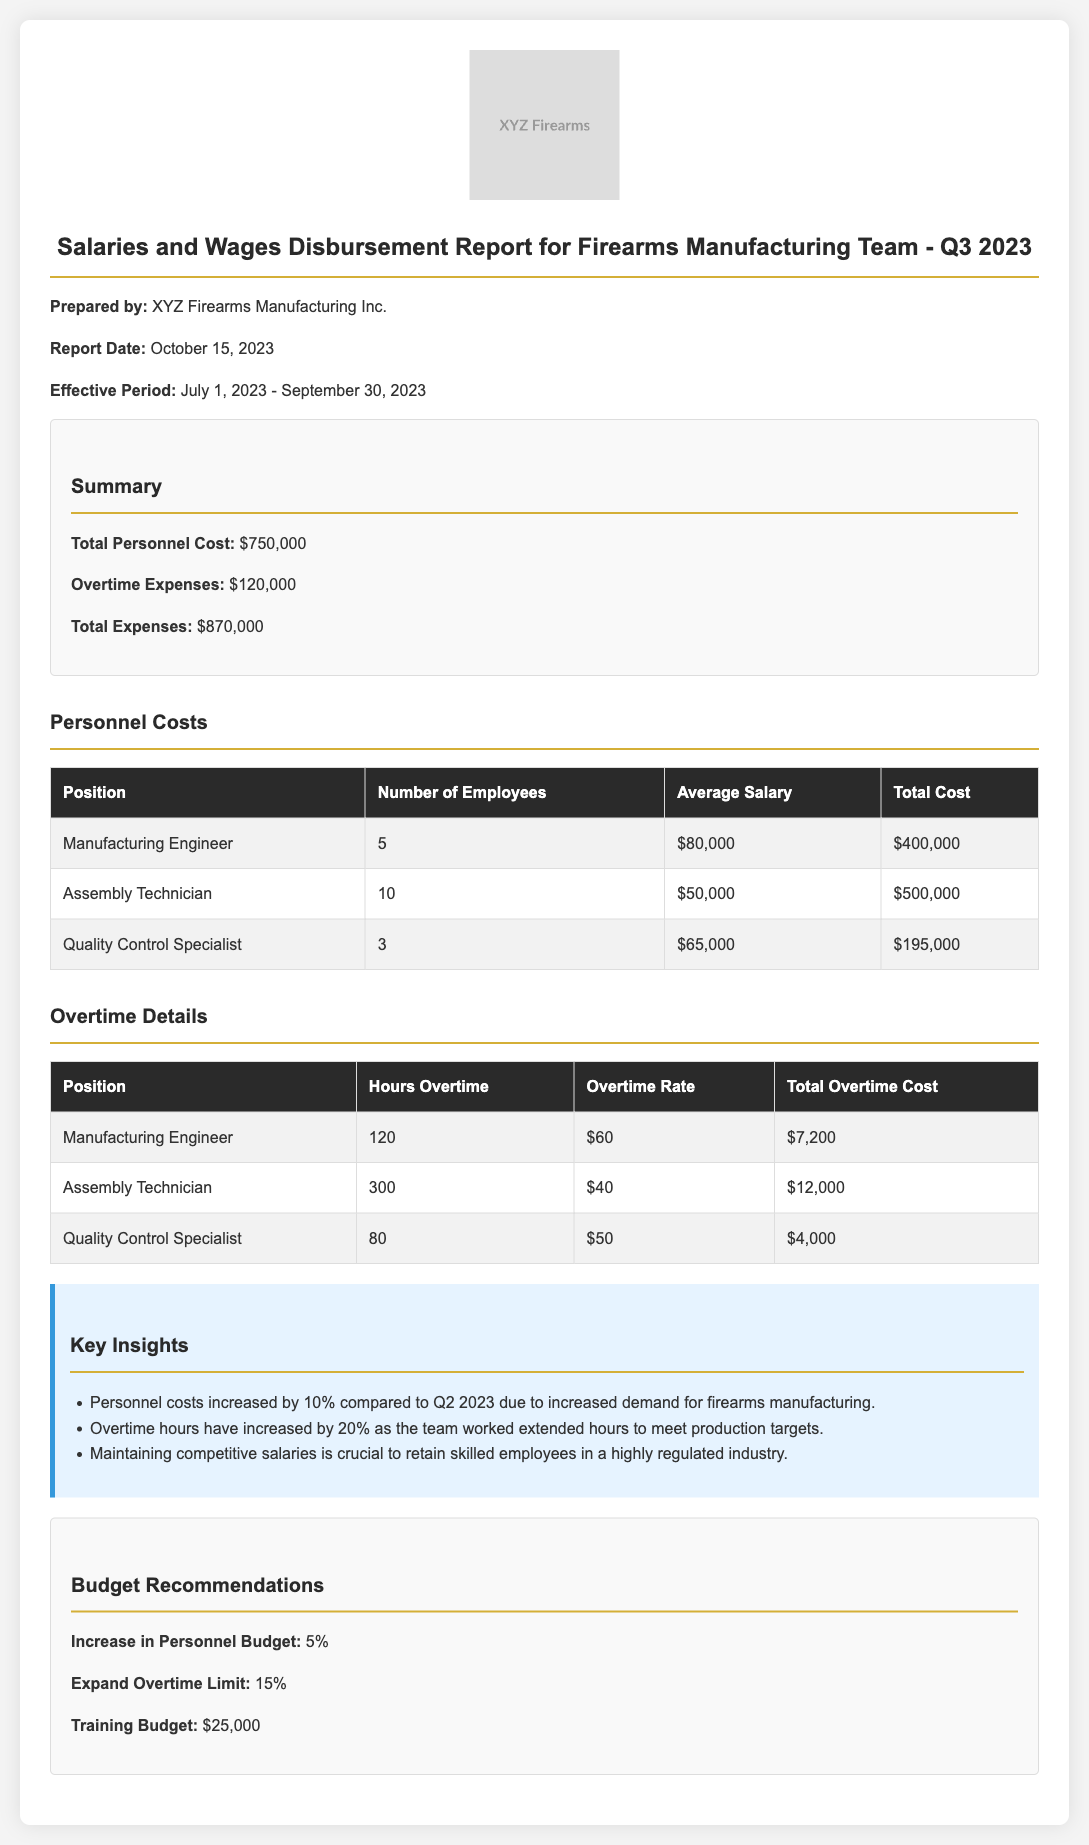What is the total personnel cost? The total personnel cost for the firearms manufacturing team during Q3 2023 is explicitly mentioned in the summary section of the document.
Answer: $750,000 What is the total overtime expense? The document provides the total overtime expense in the summary section, detailing how much was spent on overtime for the team.
Answer: $120,000 How many Assembly Technicians are there? The total number of Assembly Technicians is listed under the "Personnel Costs" section in the table.
Answer: 10 What was the average salary of a Manufacturing Engineer? The average salary for Manufacturing Engineers is specified in the personnel costs table.
Answer: $80,000 How many hours of overtime did Quality Control Specialists work? This information is available in the "Overtime Details" table, specifically for Quality Control Specialists.
Answer: 80 Why did personnel costs increase compared to Q2 2023? The reason for the increase is provided in the "Key Insights" section, describing the demand for firearms manufacturing.
Answer: Increased demand What percentage increase is recommended for the personnel budget? The recommended increase is stated in the "Budget Recommendations" section of the document.
Answer: 5% What was the total cost for Quality Control Specialists? The total cost for Quality Control Specialists is displayed in the personnel costs table.
Answer: $195,000 What is the recommended training budget? The training budget recommendation is outlined in the "Budget Recommendations" section of the document.
Answer: $25,000 